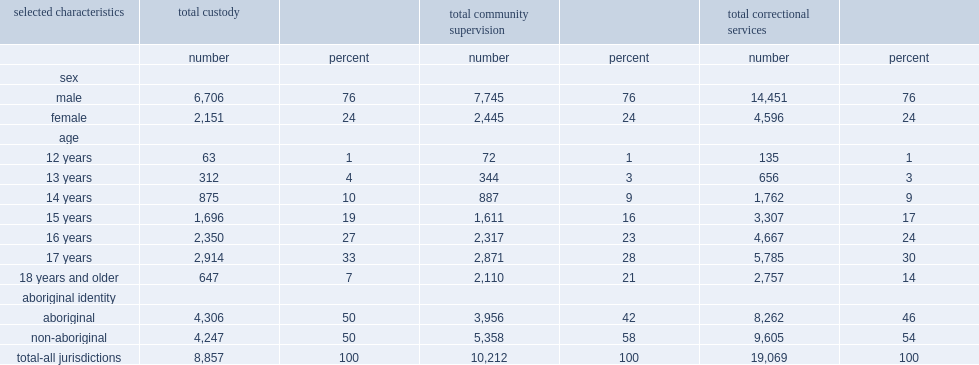In 2016/2017, how many percent of youth admitted into correctional services were male? 76.0. How many percent of custody admissions did female youth account for? 24.0. How many percent of community supervision admissions did female youth account for? 24.0. How many percent of admissions did youth aged 12 and 13 account to correctional services? 4. How many percent of admissions did aboriginal youth account to correctional services in 2016/2017? 46.0. Aboriginal youth are overrepresented in both custody and community supervision, how many percent of custody admissions? 50.0. Aboriginal youth are overrepresented in both custody and community supervision, how many percent of community admissions? 42.0. 